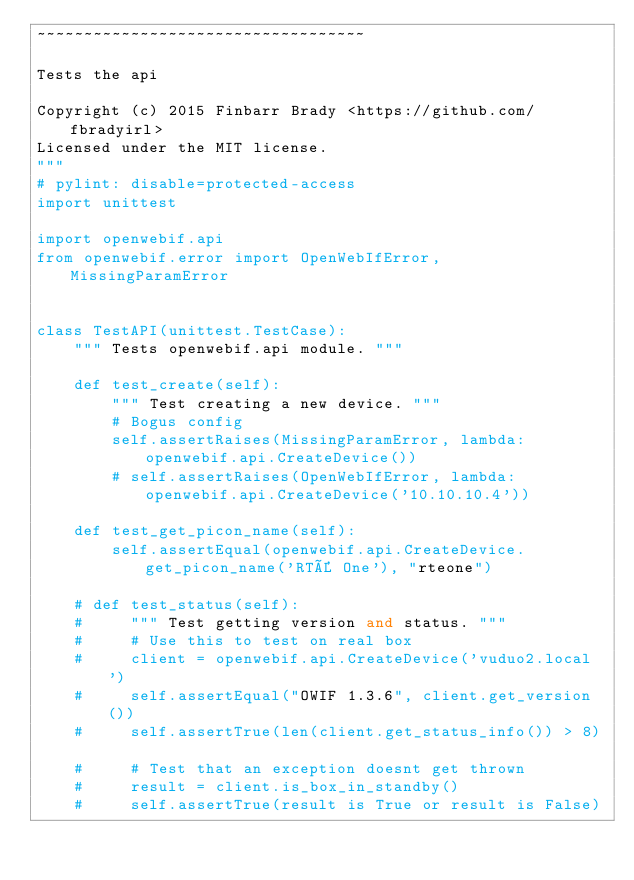<code> <loc_0><loc_0><loc_500><loc_500><_Python_>~~~~~~~~~~~~~~~~~~~~~~~~~~~~~~~~~~~

Tests the api

Copyright (c) 2015 Finbarr Brady <https://github.com/fbradyirl>
Licensed under the MIT license.
"""
# pylint: disable=protected-access
import unittest

import openwebif.api
from openwebif.error import OpenWebIfError, MissingParamError


class TestAPI(unittest.TestCase):
    """ Tests openwebif.api module. """

    def test_create(self):
        """ Test creating a new device. """
        # Bogus config
        self.assertRaises(MissingParamError, lambda: openwebif.api.CreateDevice())
        # self.assertRaises(OpenWebIfError, lambda: openwebif.api.CreateDevice('10.10.10.4'))

    def test_get_picon_name(self):
        self.assertEqual(openwebif.api.CreateDevice.get_picon_name('RTÉ One'), "rteone")

    # def test_status(self):
    #     """ Test getting version and status. """
    #     # Use this to test on real box
    #     client = openwebif.api.CreateDevice('vuduo2.local')
    #     self.assertEqual("OWIF 1.3.6", client.get_version())
    #     self.assertTrue(len(client.get_status_info()) > 8)

    #     # Test that an exception doesnt get thrown
    #     result = client.is_box_in_standby()
    #     self.assertTrue(result is True or result is False)
</code> 